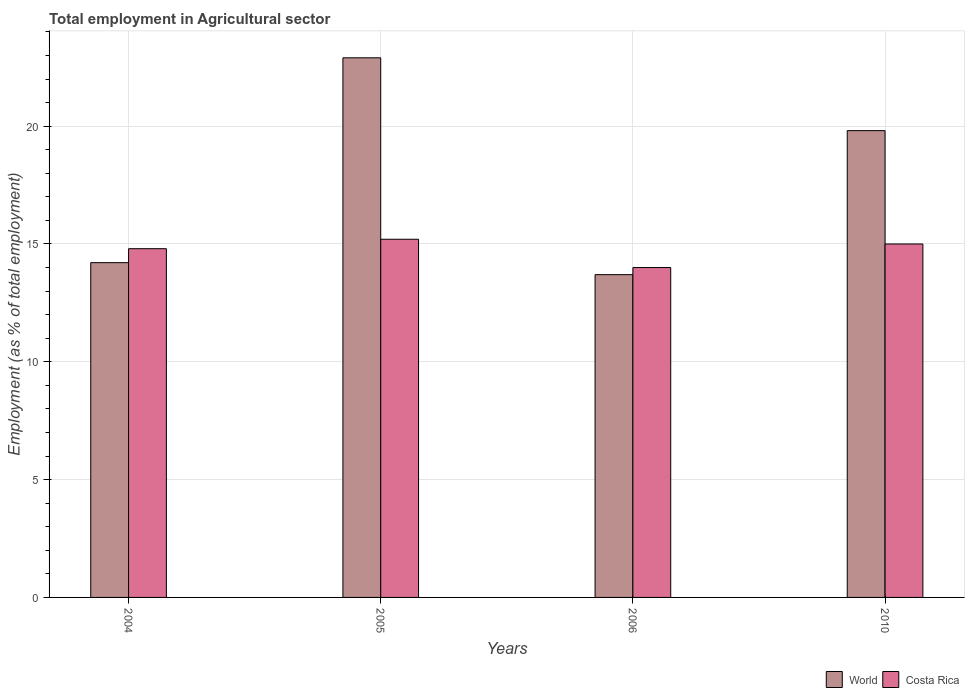How many different coloured bars are there?
Keep it short and to the point. 2. Are the number of bars on each tick of the X-axis equal?
Your answer should be very brief. Yes. What is the label of the 4th group of bars from the left?
Offer a terse response. 2010. In how many cases, is the number of bars for a given year not equal to the number of legend labels?
Provide a short and direct response. 0. What is the employment in agricultural sector in World in 2004?
Give a very brief answer. 14.21. Across all years, what is the maximum employment in agricultural sector in World?
Your response must be concise. 22.9. Across all years, what is the minimum employment in agricultural sector in World?
Give a very brief answer. 13.7. What is the difference between the employment in agricultural sector in Costa Rica in 2004 and that in 2006?
Make the answer very short. 0.8. What is the difference between the employment in agricultural sector in Costa Rica in 2010 and the employment in agricultural sector in World in 2006?
Your response must be concise. 1.3. What is the average employment in agricultural sector in World per year?
Your response must be concise. 17.65. In the year 2006, what is the difference between the employment in agricultural sector in World and employment in agricultural sector in Costa Rica?
Ensure brevity in your answer.  -0.3. What is the ratio of the employment in agricultural sector in Costa Rica in 2004 to that in 2005?
Keep it short and to the point. 0.97. Is the difference between the employment in agricultural sector in World in 2004 and 2010 greater than the difference between the employment in agricultural sector in Costa Rica in 2004 and 2010?
Provide a short and direct response. No. What is the difference between the highest and the second highest employment in agricultural sector in Costa Rica?
Make the answer very short. 0.2. What is the difference between the highest and the lowest employment in agricultural sector in Costa Rica?
Your response must be concise. 1.2. In how many years, is the employment in agricultural sector in World greater than the average employment in agricultural sector in World taken over all years?
Your response must be concise. 2. What does the 1st bar from the left in 2006 represents?
Your response must be concise. World. What does the 2nd bar from the right in 2004 represents?
Give a very brief answer. World. Are all the bars in the graph horizontal?
Your response must be concise. No. How many years are there in the graph?
Ensure brevity in your answer.  4. Are the values on the major ticks of Y-axis written in scientific E-notation?
Your response must be concise. No. Does the graph contain any zero values?
Give a very brief answer. No. Where does the legend appear in the graph?
Give a very brief answer. Bottom right. What is the title of the graph?
Offer a terse response. Total employment in Agricultural sector. What is the label or title of the Y-axis?
Provide a succinct answer. Employment (as % of total employment). What is the Employment (as % of total employment) in World in 2004?
Offer a very short reply. 14.21. What is the Employment (as % of total employment) in Costa Rica in 2004?
Your answer should be very brief. 14.8. What is the Employment (as % of total employment) in World in 2005?
Your answer should be very brief. 22.9. What is the Employment (as % of total employment) in Costa Rica in 2005?
Ensure brevity in your answer.  15.2. What is the Employment (as % of total employment) of World in 2006?
Your answer should be very brief. 13.7. What is the Employment (as % of total employment) of World in 2010?
Make the answer very short. 19.81. What is the Employment (as % of total employment) of Costa Rica in 2010?
Give a very brief answer. 15. Across all years, what is the maximum Employment (as % of total employment) in World?
Offer a very short reply. 22.9. Across all years, what is the maximum Employment (as % of total employment) of Costa Rica?
Provide a succinct answer. 15.2. Across all years, what is the minimum Employment (as % of total employment) in World?
Give a very brief answer. 13.7. Across all years, what is the minimum Employment (as % of total employment) of Costa Rica?
Ensure brevity in your answer.  14. What is the total Employment (as % of total employment) in World in the graph?
Your answer should be compact. 70.62. What is the difference between the Employment (as % of total employment) in World in 2004 and that in 2005?
Offer a very short reply. -8.69. What is the difference between the Employment (as % of total employment) in Costa Rica in 2004 and that in 2005?
Offer a very short reply. -0.4. What is the difference between the Employment (as % of total employment) of World in 2004 and that in 2006?
Provide a short and direct response. 0.51. What is the difference between the Employment (as % of total employment) in Costa Rica in 2004 and that in 2006?
Offer a very short reply. 0.8. What is the difference between the Employment (as % of total employment) in World in 2004 and that in 2010?
Your response must be concise. -5.6. What is the difference between the Employment (as % of total employment) in Costa Rica in 2004 and that in 2010?
Provide a succinct answer. -0.2. What is the difference between the Employment (as % of total employment) of World in 2005 and that in 2006?
Your answer should be compact. 9.2. What is the difference between the Employment (as % of total employment) of World in 2005 and that in 2010?
Provide a short and direct response. 3.09. What is the difference between the Employment (as % of total employment) in World in 2006 and that in 2010?
Offer a very short reply. -6.11. What is the difference between the Employment (as % of total employment) of Costa Rica in 2006 and that in 2010?
Provide a short and direct response. -1. What is the difference between the Employment (as % of total employment) in World in 2004 and the Employment (as % of total employment) in Costa Rica in 2005?
Your answer should be very brief. -0.99. What is the difference between the Employment (as % of total employment) of World in 2004 and the Employment (as % of total employment) of Costa Rica in 2006?
Your answer should be very brief. 0.21. What is the difference between the Employment (as % of total employment) in World in 2004 and the Employment (as % of total employment) in Costa Rica in 2010?
Offer a terse response. -0.79. What is the difference between the Employment (as % of total employment) of World in 2005 and the Employment (as % of total employment) of Costa Rica in 2006?
Keep it short and to the point. 8.9. What is the difference between the Employment (as % of total employment) of World in 2005 and the Employment (as % of total employment) of Costa Rica in 2010?
Your answer should be very brief. 7.9. What is the difference between the Employment (as % of total employment) in World in 2006 and the Employment (as % of total employment) in Costa Rica in 2010?
Keep it short and to the point. -1.3. What is the average Employment (as % of total employment) of World per year?
Make the answer very short. 17.65. What is the average Employment (as % of total employment) of Costa Rica per year?
Keep it short and to the point. 14.75. In the year 2004, what is the difference between the Employment (as % of total employment) of World and Employment (as % of total employment) of Costa Rica?
Provide a short and direct response. -0.59. In the year 2005, what is the difference between the Employment (as % of total employment) of World and Employment (as % of total employment) of Costa Rica?
Give a very brief answer. 7.7. In the year 2006, what is the difference between the Employment (as % of total employment) in World and Employment (as % of total employment) in Costa Rica?
Provide a succinct answer. -0.3. In the year 2010, what is the difference between the Employment (as % of total employment) in World and Employment (as % of total employment) in Costa Rica?
Offer a very short reply. 4.81. What is the ratio of the Employment (as % of total employment) of World in 2004 to that in 2005?
Offer a very short reply. 0.62. What is the ratio of the Employment (as % of total employment) of Costa Rica in 2004 to that in 2005?
Offer a very short reply. 0.97. What is the ratio of the Employment (as % of total employment) of World in 2004 to that in 2006?
Offer a terse response. 1.04. What is the ratio of the Employment (as % of total employment) of Costa Rica in 2004 to that in 2006?
Ensure brevity in your answer.  1.06. What is the ratio of the Employment (as % of total employment) of World in 2004 to that in 2010?
Provide a short and direct response. 0.72. What is the ratio of the Employment (as % of total employment) of Costa Rica in 2004 to that in 2010?
Your answer should be very brief. 0.99. What is the ratio of the Employment (as % of total employment) of World in 2005 to that in 2006?
Make the answer very short. 1.67. What is the ratio of the Employment (as % of total employment) in Costa Rica in 2005 to that in 2006?
Your response must be concise. 1.09. What is the ratio of the Employment (as % of total employment) in World in 2005 to that in 2010?
Your answer should be very brief. 1.16. What is the ratio of the Employment (as % of total employment) of Costa Rica in 2005 to that in 2010?
Offer a terse response. 1.01. What is the ratio of the Employment (as % of total employment) in World in 2006 to that in 2010?
Ensure brevity in your answer.  0.69. What is the ratio of the Employment (as % of total employment) of Costa Rica in 2006 to that in 2010?
Give a very brief answer. 0.93. What is the difference between the highest and the second highest Employment (as % of total employment) in World?
Provide a succinct answer. 3.09. What is the difference between the highest and the lowest Employment (as % of total employment) of World?
Provide a succinct answer. 9.2. 